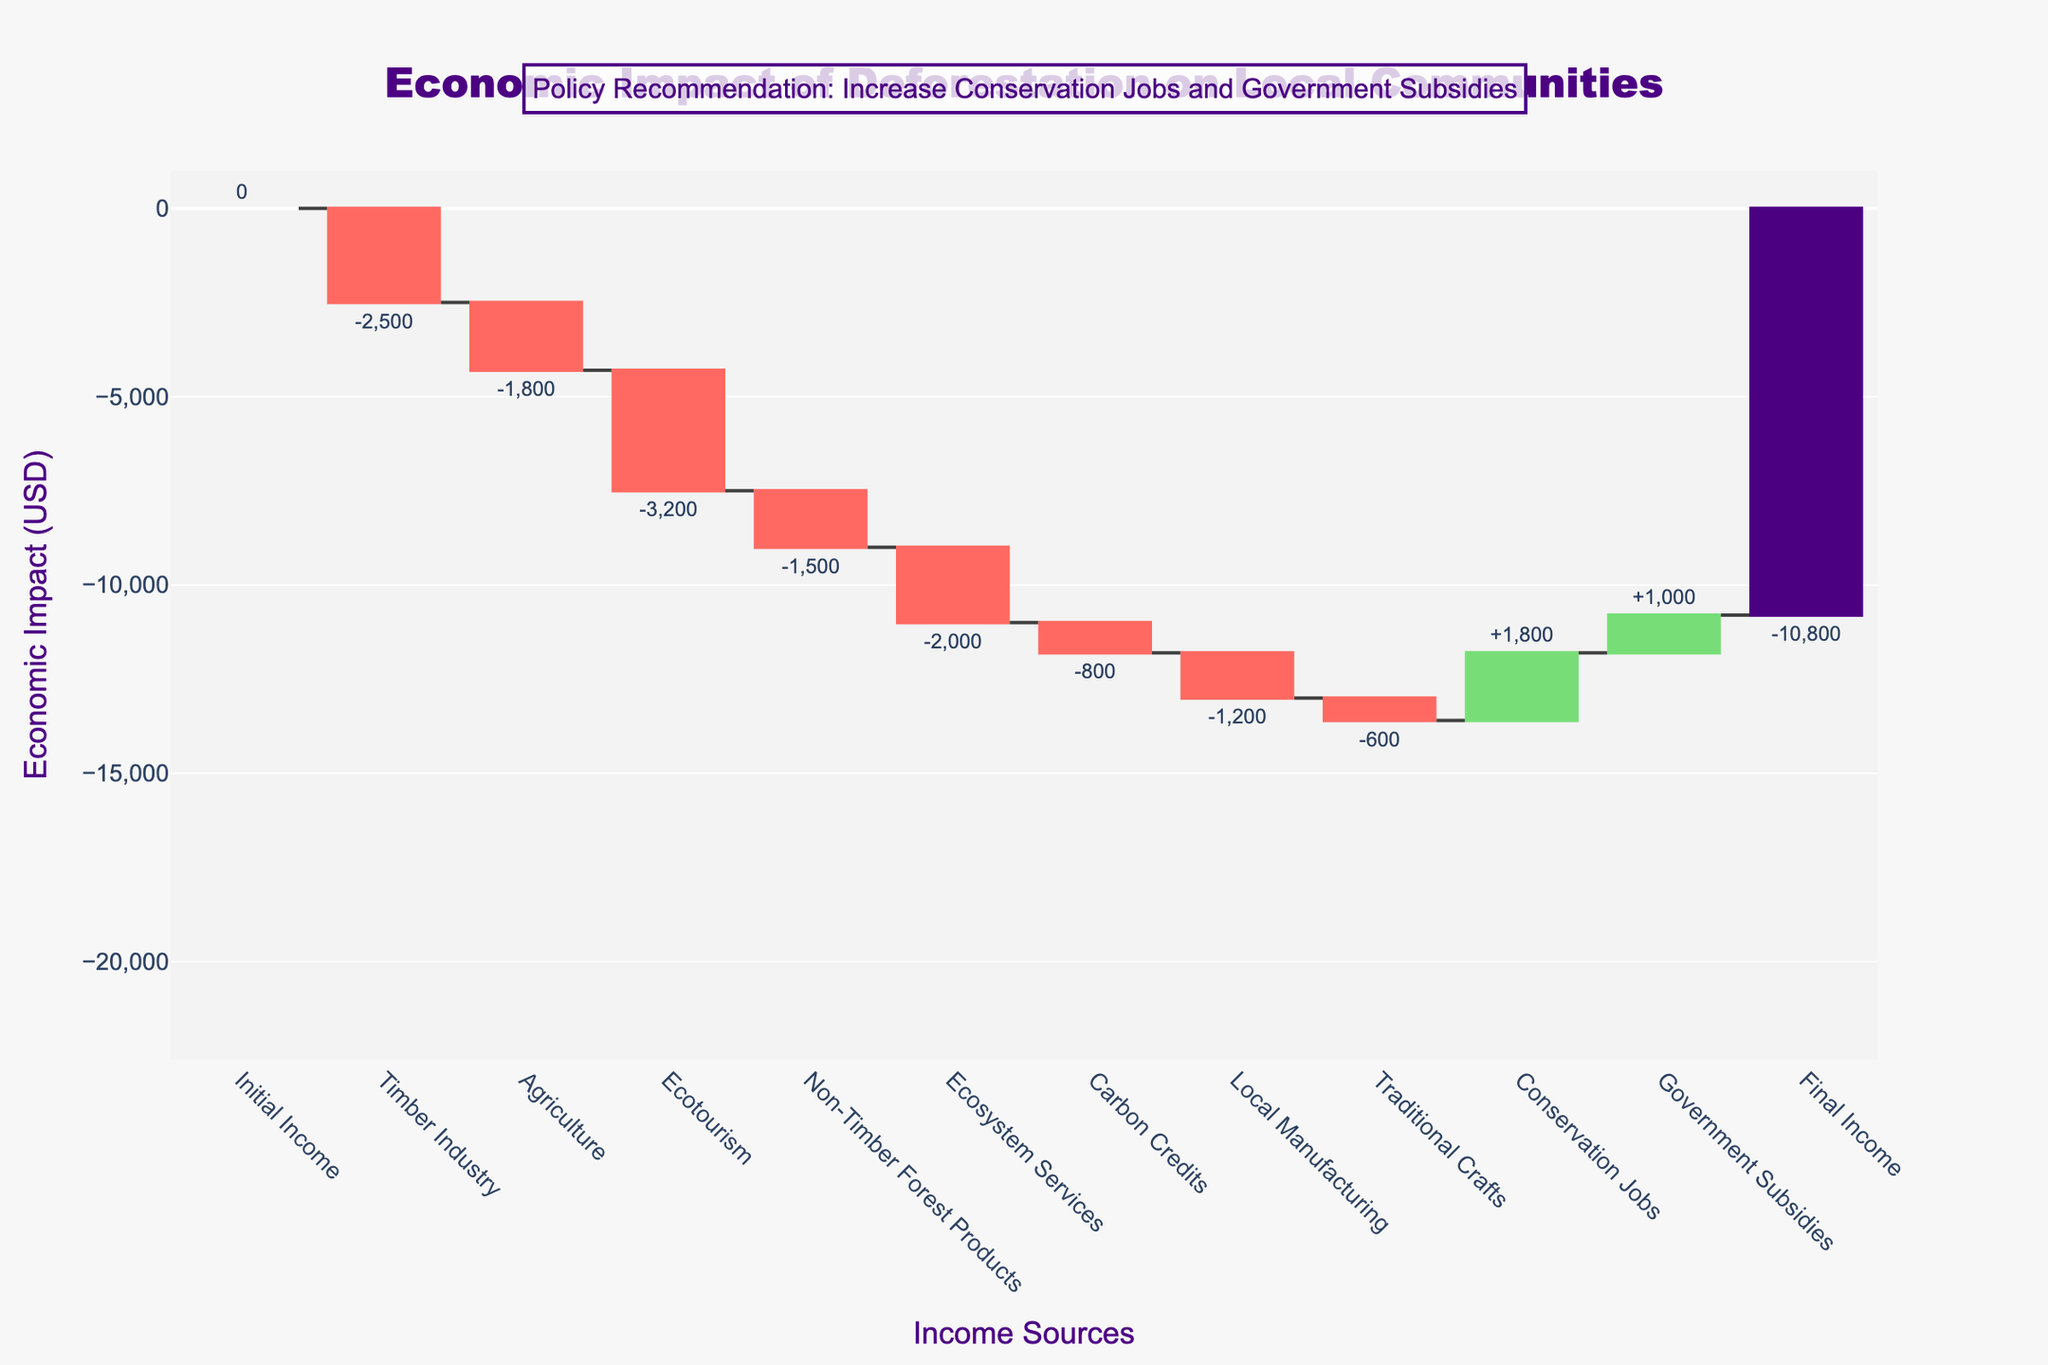What is the title of the figure? The title is located at the top of the figure and provides an overview of the subject matter depicted in the chart. This information is usually formatted in a larger and distinctive font.
Answer: Economic Impact of Deforestation on Local Communities Which income source experiences the largest negative impact due to deforestation? Investigate each bar that represents an income source. The one with the largest drop from the starting level is the largest negative impact.
Answer: Ecotourism What is the final economic impact on the local communities? The final cumulative value after accounting for all additions and subtractions is denoted by the last bar in the waterfall chart.
Answer: -$10,800 How many income sources are positively affected by deforestation? Positive values (those with bars extending upwards) in the chart indicate income sources that benefit from deforestation. Count the positive values.
Answer: 2 Which income source contributes the most to mitigating the negative impact of deforestation? Among the positive impacts (upward bars), identify the one with the highest value.
Answer: Conservation Jobs What is the cumulative impact after considering Timber Industry and Agriculture? Cumulatively add the value of Timber Industry and Agriculture.
Answer: -4300 Which is more negatively impacted by deforestation, Local Manufacturing or Non-Timber Forest Products? Compare the values (or heights of the bars) of Local Manufacturing and Non-Timber Forest Products to see which one is more negative.
Answer: Non-Timber Forest Products If the policy recommends increasing Conservation Jobs and Government Subsidies, how much would mitigate the total economic loss if fully implemented? Sum the positive values from Conservation Jobs and Government Subsidies.
Answer: 2800 What is the visual color indicating the biggest negative impact in the chart? Identify the color associated with the largest negative bar.
Answer: Red What is the overall impact of deforestation on traditional income sources (excluding Conservation Jobs and Government Subsidies)? Sum the values for all other categories except Conservation Jobs and Government Subsidies to find the overall impact.
Answer: -13600 